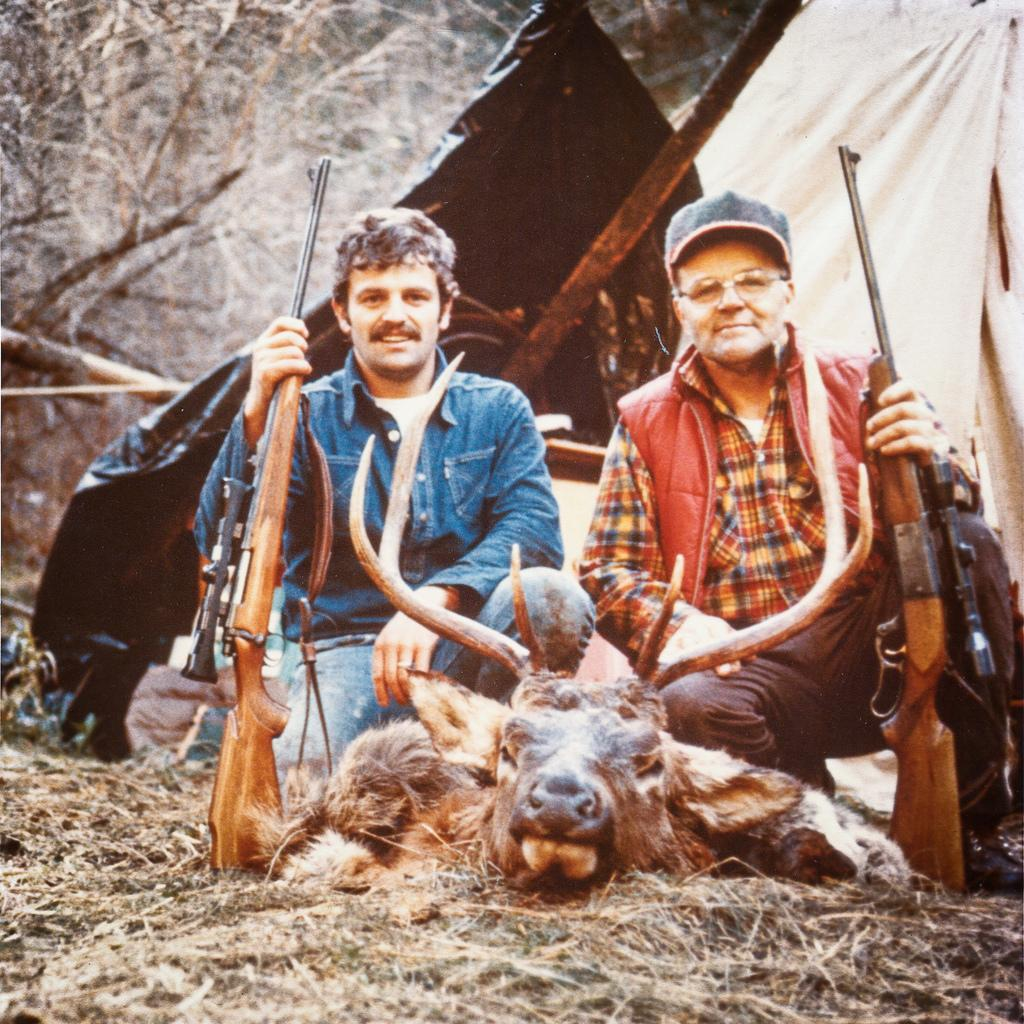What are the persons in the image holding? The persons in the image are holding a gun. What is on the ground in the image? There is a wild animal on the ground in the image. What can be seen in the background of the image? There appears to be a tent and trees in the background of the image. What type of rabbit can be seen jumping over a plough in the image? There is no rabbit or plough present in the image. What kind of paper is being used by the persons holding the gun in the image? There is no paper visible in the image; the persons are holding a gun. 